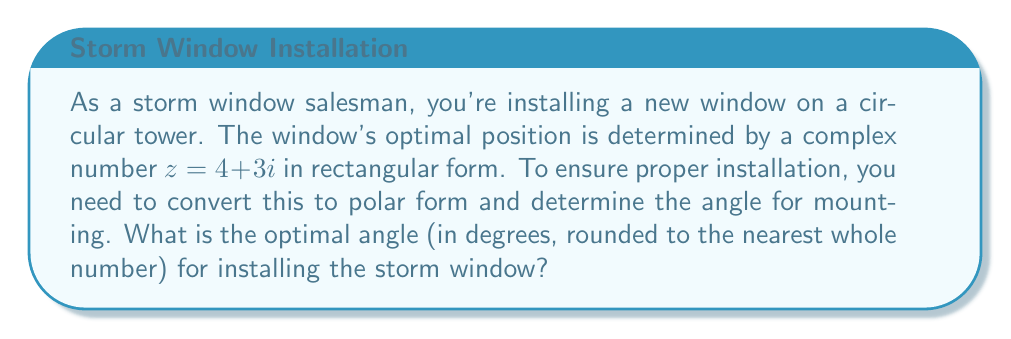Help me with this question. To solve this problem, we need to convert the complex number from rectangular form to polar form and then determine the angle.

1) The complex number in rectangular form is $z = 4 + 3i$.

2) To convert to polar form, we use the formula $z = r(\cos\theta + i\sin\theta)$, where:
   
   $r = \sqrt{a^2 + b^2}$ (magnitude)
   $\theta = \tan^{-1}(\frac{b}{a})$ (angle in radians)

3) Calculate the magnitude:
   $$r = \sqrt{4^2 + 3^2} = \sqrt{16 + 9} = \sqrt{25} = 5$$

4) Calculate the angle:
   $$\theta = \tan^{-1}(\frac{3}{4})$$

5) Convert the angle from radians to degrees:
   $$\theta_{degrees} = \theta_{radians} \cdot \frac{180^\circ}{\pi}$$

6) Using a calculator:
   $$\theta_{degrees} = \tan^{-1}(\frac{3}{4}) \cdot \frac{180^\circ}{\pi} \approx 36.87^\circ$$

7) Rounding to the nearest whole number:
   $$\theta_{degrees} \approx 37^\circ$$

Therefore, the optimal angle for installing the storm window is approximately 37 degrees.
Answer: 37 degrees 